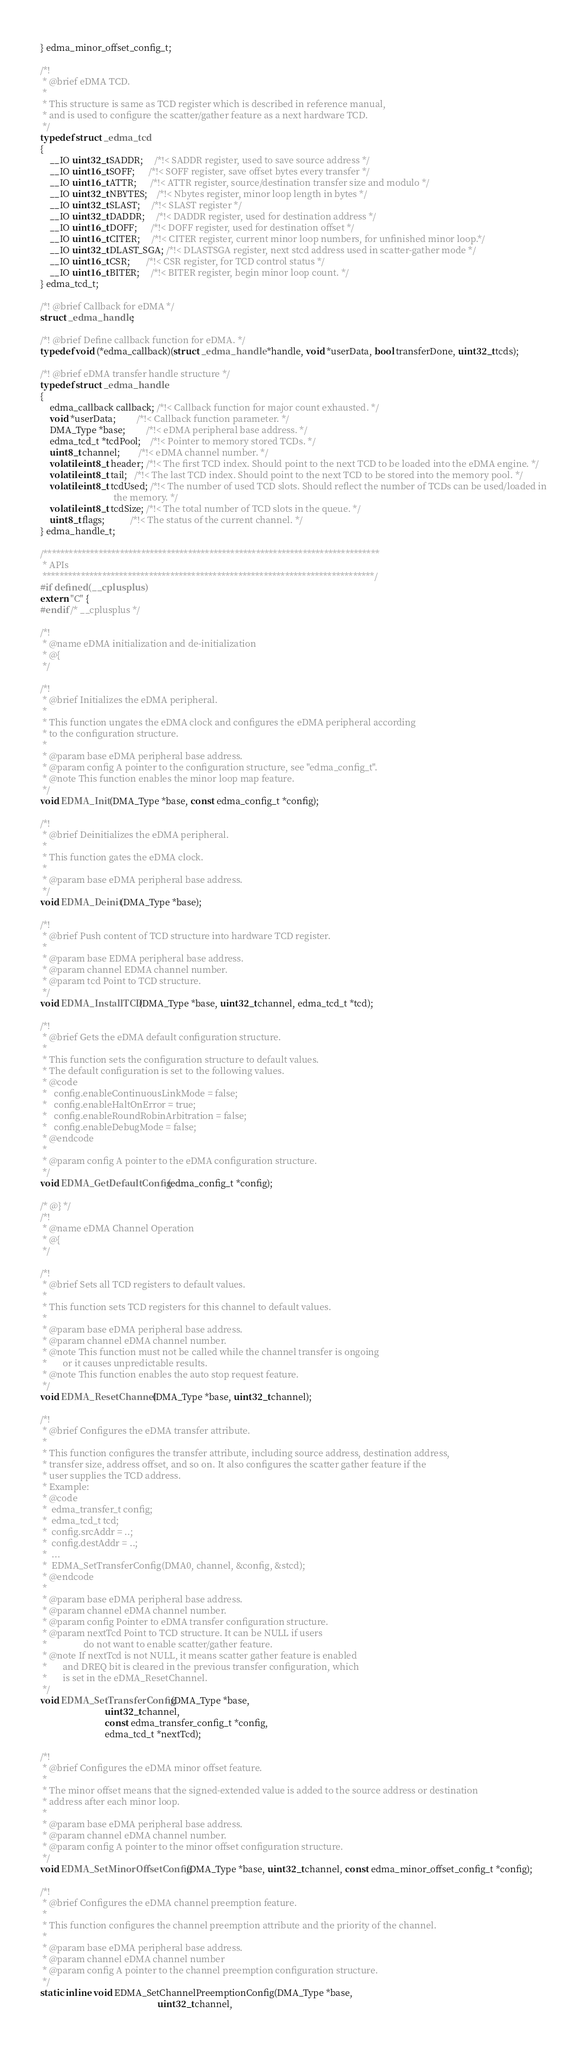<code> <loc_0><loc_0><loc_500><loc_500><_C_>} edma_minor_offset_config_t;

/*!
 * @brief eDMA TCD.
 *
 * This structure is same as TCD register which is described in reference manual,
 * and is used to configure the scatter/gather feature as a next hardware TCD.
 */
typedef struct _edma_tcd
{
    __IO uint32_t SADDR;     /*!< SADDR register, used to save source address */
    __IO uint16_t SOFF;      /*!< SOFF register, save offset bytes every transfer */
    __IO uint16_t ATTR;      /*!< ATTR register, source/destination transfer size and modulo */
    __IO uint32_t NBYTES;    /*!< Nbytes register, minor loop length in bytes */
    __IO uint32_t SLAST;     /*!< SLAST register */
    __IO uint32_t DADDR;     /*!< DADDR register, used for destination address */
    __IO uint16_t DOFF;      /*!< DOFF register, used for destination offset */
    __IO uint16_t CITER;     /*!< CITER register, current minor loop numbers, for unfinished minor loop.*/
    __IO uint32_t DLAST_SGA; /*!< DLASTSGA register, next stcd address used in scatter-gather mode */
    __IO uint16_t CSR;       /*!< CSR register, for TCD control status */
    __IO uint16_t BITER;     /*!< BITER register, begin minor loop count. */
} edma_tcd_t;

/*! @brief Callback for eDMA */
struct _edma_handle;

/*! @brief Define callback function for eDMA. */
typedef void (*edma_callback)(struct _edma_handle *handle, void *userData, bool transferDone, uint32_t tcds);

/*! @brief eDMA transfer handle structure */
typedef struct _edma_handle
{
    edma_callback callback; /*!< Callback function for major count exhausted. */
    void *userData;         /*!< Callback function parameter. */
    DMA_Type *base;         /*!< eDMA peripheral base address. */
    edma_tcd_t *tcdPool;    /*!< Pointer to memory stored TCDs. */
    uint8_t channel;        /*!< eDMA channel number. */
    volatile int8_t header; /*!< The first TCD index. Should point to the next TCD to be loaded into the eDMA engine. */
    volatile int8_t tail;   /*!< The last TCD index. Should point to the next TCD to be stored into the memory pool. */
    volatile int8_t tcdUsed; /*!< The number of used TCD slots. Should reflect the number of TCDs can be used/loaded in
                                the memory. */
    volatile int8_t tcdSize; /*!< The total number of TCD slots in the queue. */
    uint8_t flags;           /*!< The status of the current channel. */
} edma_handle_t;

/*******************************************************************************
 * APIs
 ******************************************************************************/
#if defined(__cplusplus)
extern "C" {
#endif /* __cplusplus */

/*!
 * @name eDMA initialization and de-initialization
 * @{
 */

/*!
 * @brief Initializes the eDMA peripheral.
 *
 * This function ungates the eDMA clock and configures the eDMA peripheral according
 * to the configuration structure.
 *
 * @param base eDMA peripheral base address.
 * @param config A pointer to the configuration structure, see "edma_config_t".
 * @note This function enables the minor loop map feature.
 */
void EDMA_Init(DMA_Type *base, const edma_config_t *config);

/*!
 * @brief Deinitializes the eDMA peripheral.
 *
 * This function gates the eDMA clock.
 *
 * @param base eDMA peripheral base address.
 */
void EDMA_Deinit(DMA_Type *base);

/*!
 * @brief Push content of TCD structure into hardware TCD register.
 *
 * @param base EDMA peripheral base address.
 * @param channel EDMA channel number.
 * @param tcd Point to TCD structure.
 */
void EDMA_InstallTCD(DMA_Type *base, uint32_t channel, edma_tcd_t *tcd);

/*!
 * @brief Gets the eDMA default configuration structure.
 *
 * This function sets the configuration structure to default values.
 * The default configuration is set to the following values.
 * @code
 *   config.enableContinuousLinkMode = false;
 *   config.enableHaltOnError = true;
 *   config.enableRoundRobinArbitration = false;
 *   config.enableDebugMode = false;
 * @endcode
 *
 * @param config A pointer to the eDMA configuration structure.
 */
void EDMA_GetDefaultConfig(edma_config_t *config);

/* @} */
/*!
 * @name eDMA Channel Operation
 * @{
 */

/*!
 * @brief Sets all TCD registers to default values.
 *
 * This function sets TCD registers for this channel to default values.
 *
 * @param base eDMA peripheral base address.
 * @param channel eDMA channel number.
 * @note This function must not be called while the channel transfer is ongoing
 *       or it causes unpredictable results.
 * @note This function enables the auto stop request feature.
 */
void EDMA_ResetChannel(DMA_Type *base, uint32_t channel);

/*!
 * @brief Configures the eDMA transfer attribute.
 *
 * This function configures the transfer attribute, including source address, destination address,
 * transfer size, address offset, and so on. It also configures the scatter gather feature if the
 * user supplies the TCD address.
 * Example:
 * @code
 *  edma_transfer_t config;
 *  edma_tcd_t tcd;
 *  config.srcAddr = ..;
 *  config.destAddr = ..;
 *  ...
 *  EDMA_SetTransferConfig(DMA0, channel, &config, &stcd);
 * @endcode
 *
 * @param base eDMA peripheral base address.
 * @param channel eDMA channel number.
 * @param config Pointer to eDMA transfer configuration structure.
 * @param nextTcd Point to TCD structure. It can be NULL if users
 *                do not want to enable scatter/gather feature.
 * @note If nextTcd is not NULL, it means scatter gather feature is enabled
 *       and DREQ bit is cleared in the previous transfer configuration, which
 *       is set in the eDMA_ResetChannel.
 */
void EDMA_SetTransferConfig(DMA_Type *base,
                            uint32_t channel,
                            const edma_transfer_config_t *config,
                            edma_tcd_t *nextTcd);

/*!
 * @brief Configures the eDMA minor offset feature.
 *
 * The minor offset means that the signed-extended value is added to the source address or destination
 * address after each minor loop.
 *
 * @param base eDMA peripheral base address.
 * @param channel eDMA channel number.
 * @param config A pointer to the minor offset configuration structure.
 */
void EDMA_SetMinorOffsetConfig(DMA_Type *base, uint32_t channel, const edma_minor_offset_config_t *config);

/*!
 * @brief Configures the eDMA channel preemption feature.
 *
 * This function configures the channel preemption attribute and the priority of the channel.
 *
 * @param base eDMA peripheral base address.
 * @param channel eDMA channel number
 * @param config A pointer to the channel preemption configuration structure.
 */
static inline void EDMA_SetChannelPreemptionConfig(DMA_Type *base,
                                                   uint32_t channel,</code> 